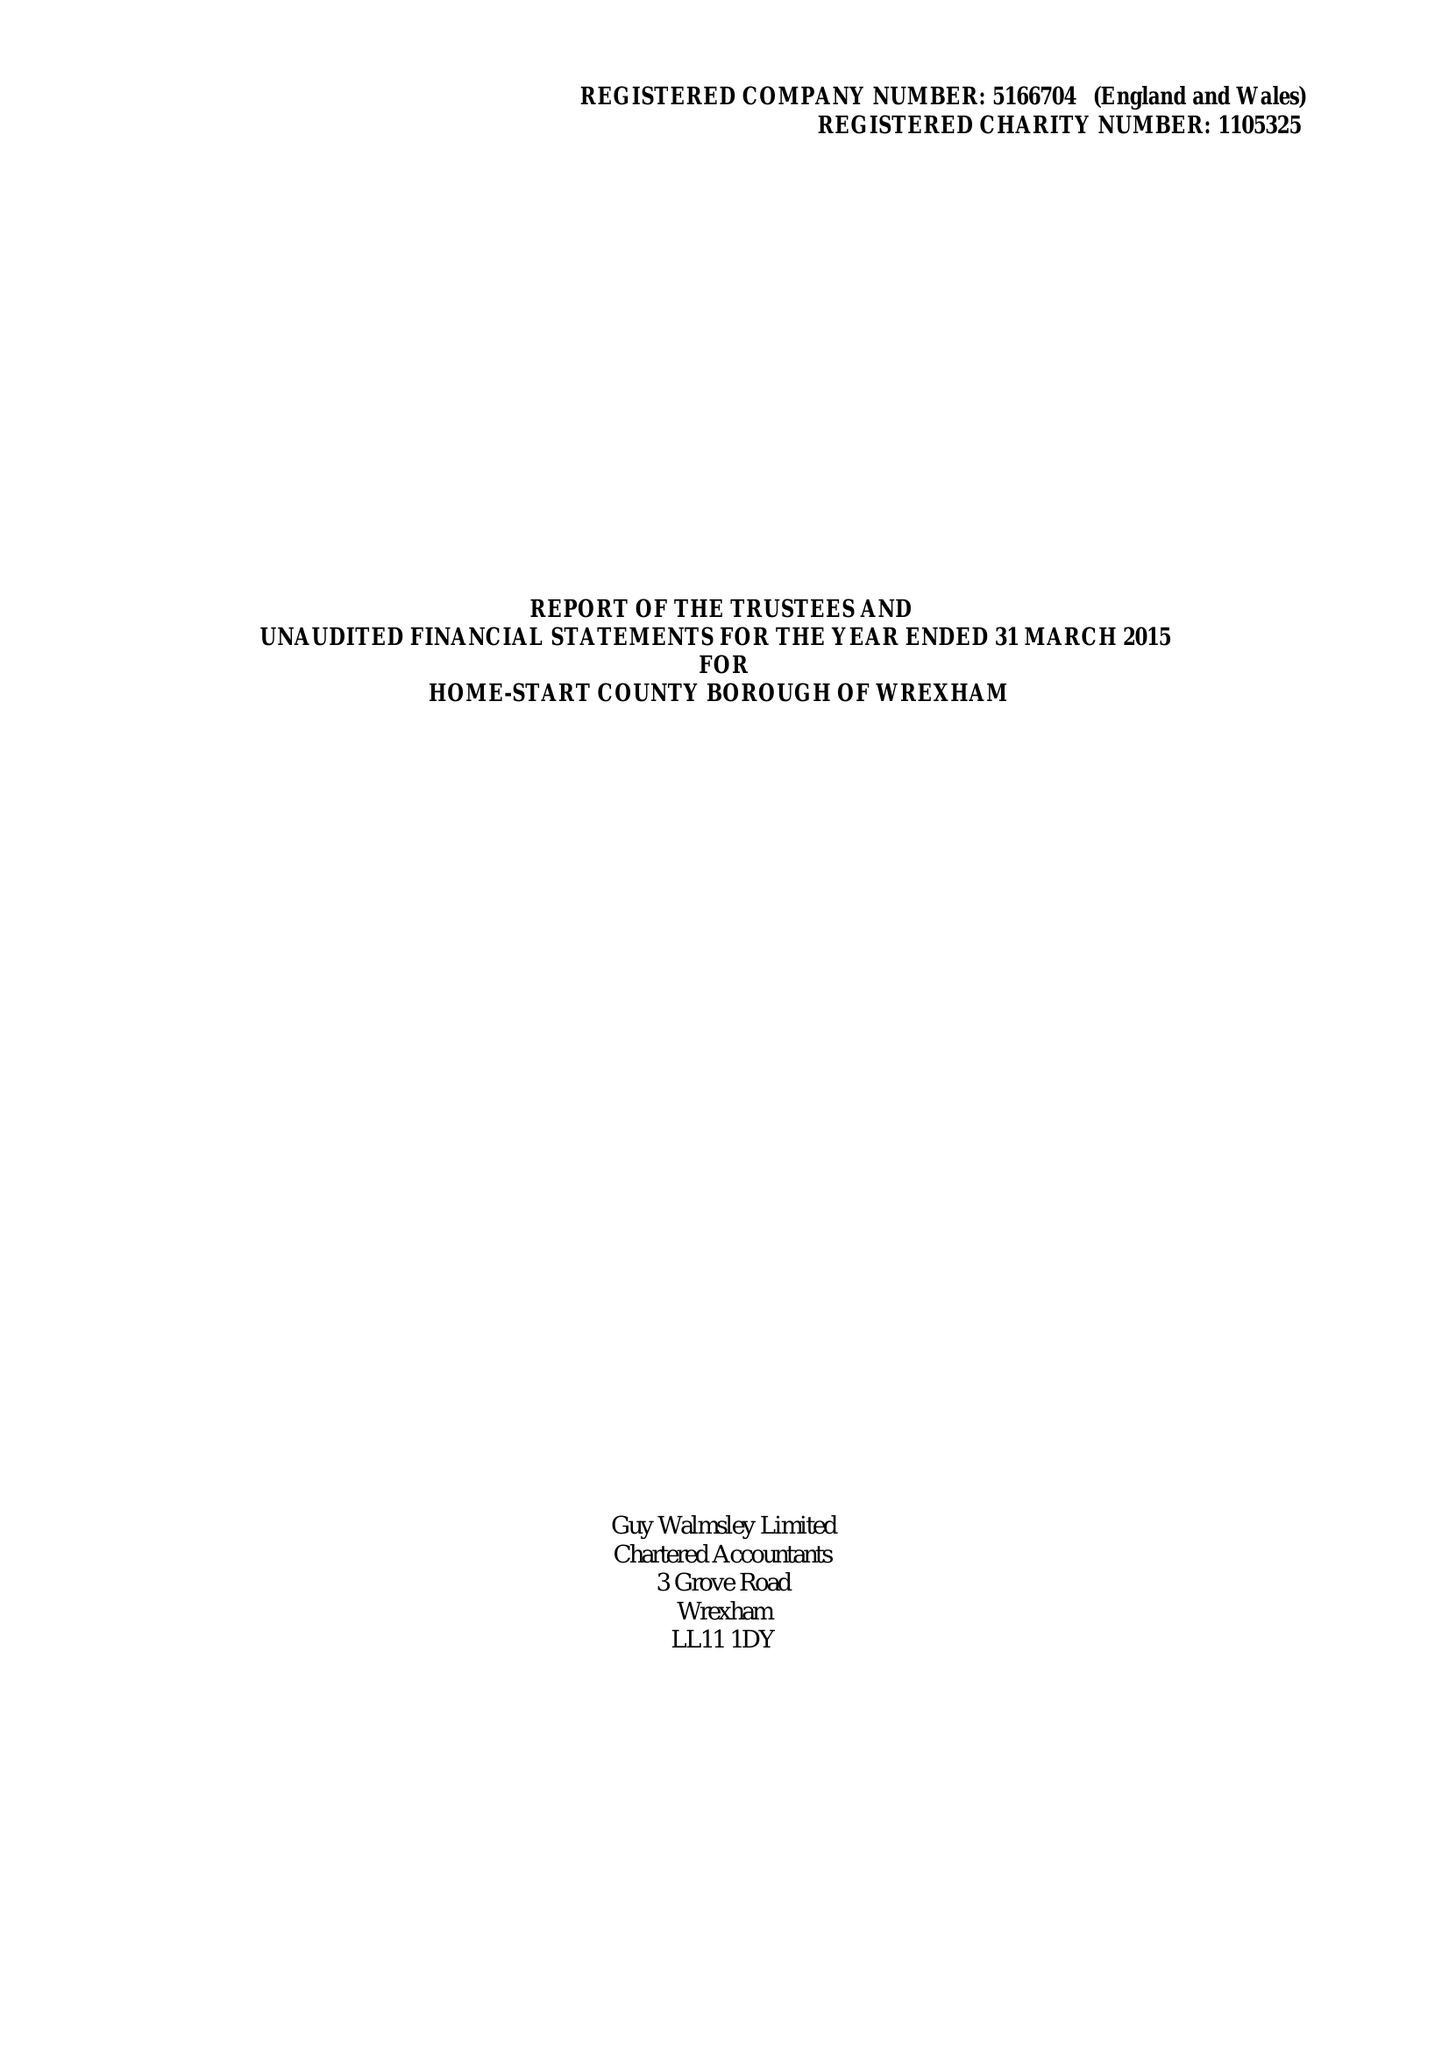What is the value for the address__post_town?
Answer the question using a single word or phrase. WREXHAM 